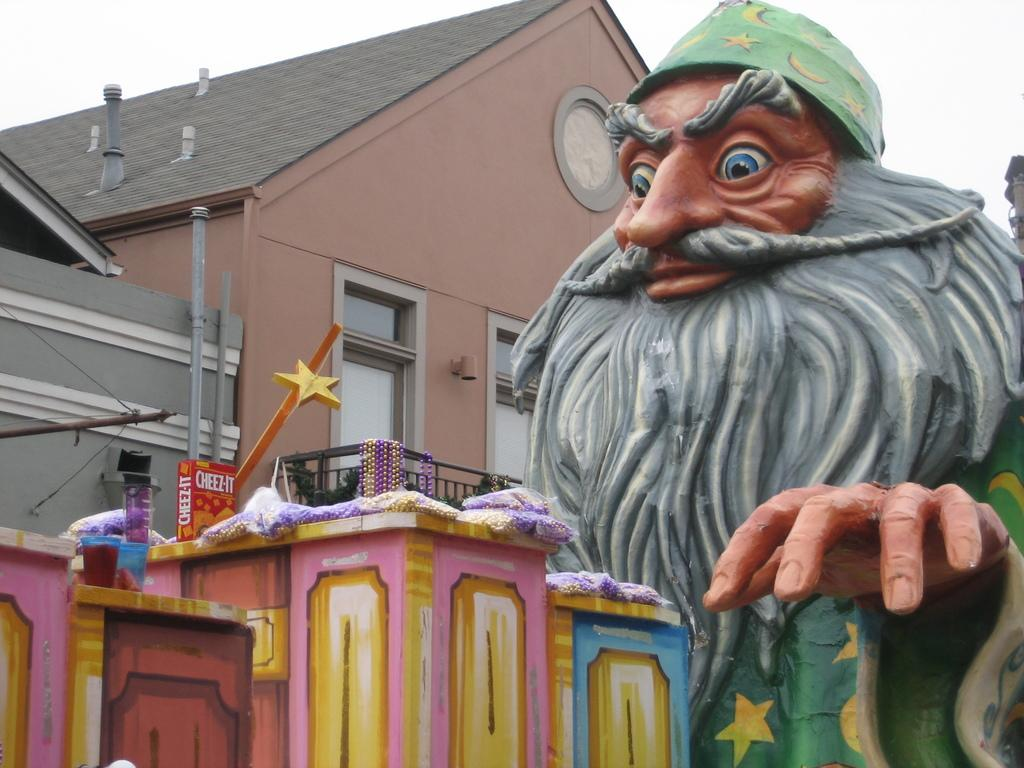What is the main subject in the image? There is a statue in the image. Can you describe the appearance of the statue? The statue has different colors. What can be seen in the background of the image? There is a building and glass windows visible in the background. How would you describe the sky in the image? The sky appears to be white in color. How does the statue react to the earthquake in the image? There is no earthquake present in the image, so the statue's reaction cannot be determined. What type of servant is attending to the statue in the image? There are no servants present in the image; it only features a statue and the surrounding environment. 